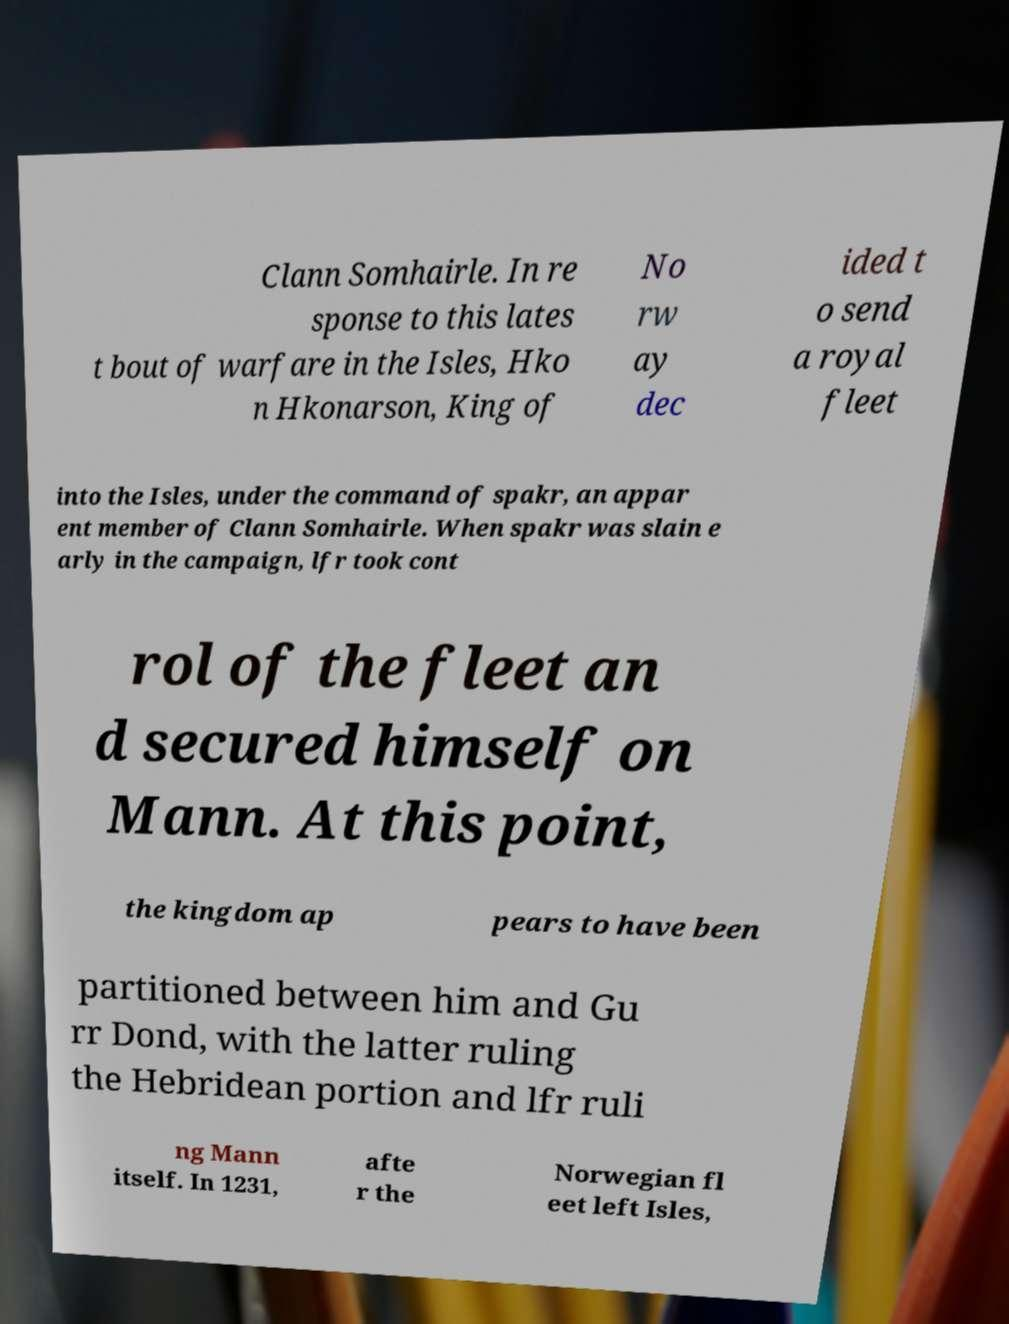Could you extract and type out the text from this image? Clann Somhairle. In re sponse to this lates t bout of warfare in the Isles, Hko n Hkonarson, King of No rw ay dec ided t o send a royal fleet into the Isles, under the command of spakr, an appar ent member of Clann Somhairle. When spakr was slain e arly in the campaign, lfr took cont rol of the fleet an d secured himself on Mann. At this point, the kingdom ap pears to have been partitioned between him and Gu rr Dond, with the latter ruling the Hebridean portion and lfr ruli ng Mann itself. In 1231, afte r the Norwegian fl eet left Isles, 